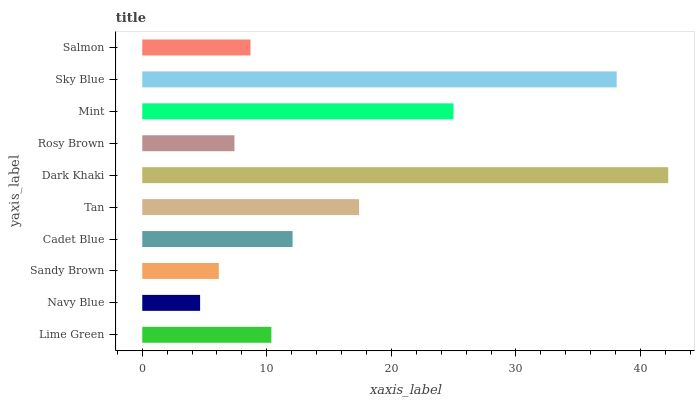Is Navy Blue the minimum?
Answer yes or no. Yes. Is Dark Khaki the maximum?
Answer yes or no. Yes. Is Sandy Brown the minimum?
Answer yes or no. No. Is Sandy Brown the maximum?
Answer yes or no. No. Is Sandy Brown greater than Navy Blue?
Answer yes or no. Yes. Is Navy Blue less than Sandy Brown?
Answer yes or no. Yes. Is Navy Blue greater than Sandy Brown?
Answer yes or no. No. Is Sandy Brown less than Navy Blue?
Answer yes or no. No. Is Cadet Blue the high median?
Answer yes or no. Yes. Is Lime Green the low median?
Answer yes or no. Yes. Is Sky Blue the high median?
Answer yes or no. No. Is Sandy Brown the low median?
Answer yes or no. No. 